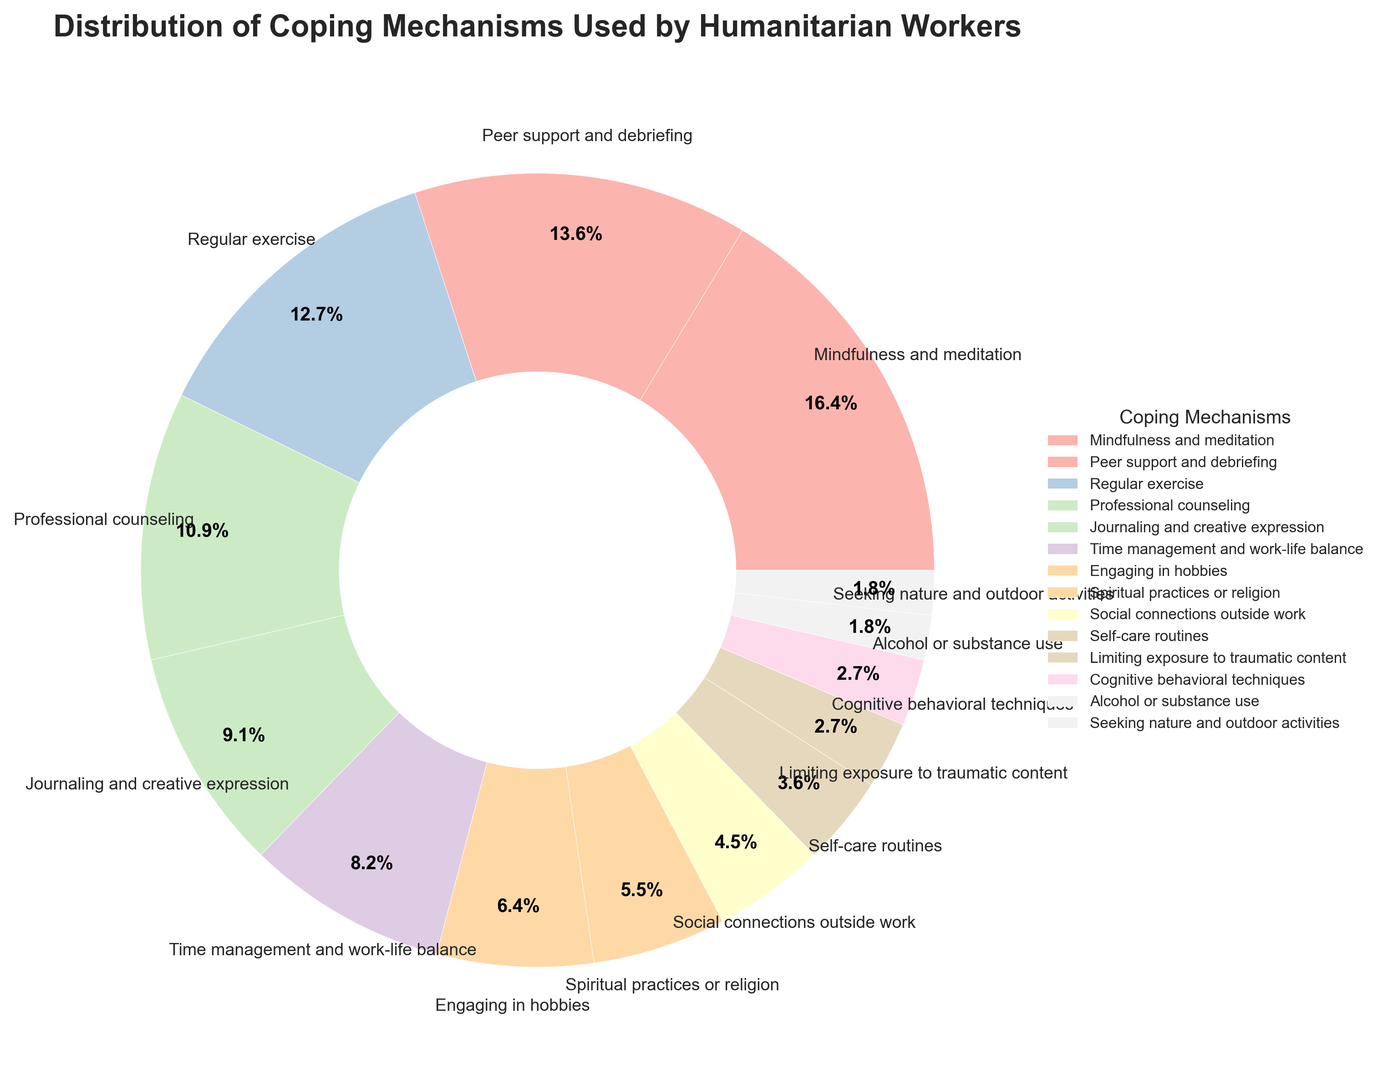Which coping mechanism is used the most by humanitarian workers? By observing the largest wedge in the pie chart, we can see that "Mindfulness and meditation" has the highest percentage at 18%.
Answer: Mindfulness and meditation What is the combined percentage of "Professional counseling" and "Journaling and creative expression"? We add the percentages of these two coping mechanisms: 12% (Professional counseling) + 10% (Journaling and creative expression) = 22%.
Answer: 22% How does the percentage of "Regular exercise" compare to "Engaging in hobbies"? We can compare the percentages directly: "Regular exercise" is 14%, and "Engaging in hobbies" is 7%. Since 14% > 7%, "Regular exercise" is used more.
Answer: Regular exercise is used more Which two coping mechanisms are used the least by humanitarian workers? By identifying the smallest wedges in the pie chart, we find that "Alcohol or substance use" and "Seeking nature and outdoor activities" both have the smallest percentages at 2% each.
Answer: Alcohol or substance use, Seeking nature and outdoor activities What percentage of humanitarian workers use "Social connections outside work" to manage stress? We can directly read the percentage from the pie chart: 5%.
Answer: 5% How much higher is the usage of "Peer support and debriefing" compared to "Limiting exposure to traumatic content"? Subtract the percentage of "Limiting exposure to traumatic content" (3%) from "Peer support and debriefing" (15%): 15% - 3% = 12%.
Answer: 12% What is the difference in percentage between "Time management and work-life balance" and "Spiritual practices or religion"? Subtract the percentage of "Spiritual practices or religion" (6%) from "Time management and work-life balance" (9%): 9% - 6% = 3%.
Answer: 3% Which coping mechanism has a slightly higher percentage, "Peer support and debriefing" or "Regular exercise"? Comparing the percentages, "Peer support and debriefing" has 15%, while "Regular exercise" has 14%. Thus, "Peer support and debriefing" is slightly higher.
Answer: Peer support and debriefing What do the colors represent in this pie chart? Each color in the pie chart corresponds to a different coping mechanism, visually distinguishing the various methods used by humanitarian workers to manage stress.
Answer: Different coping mechanisms 